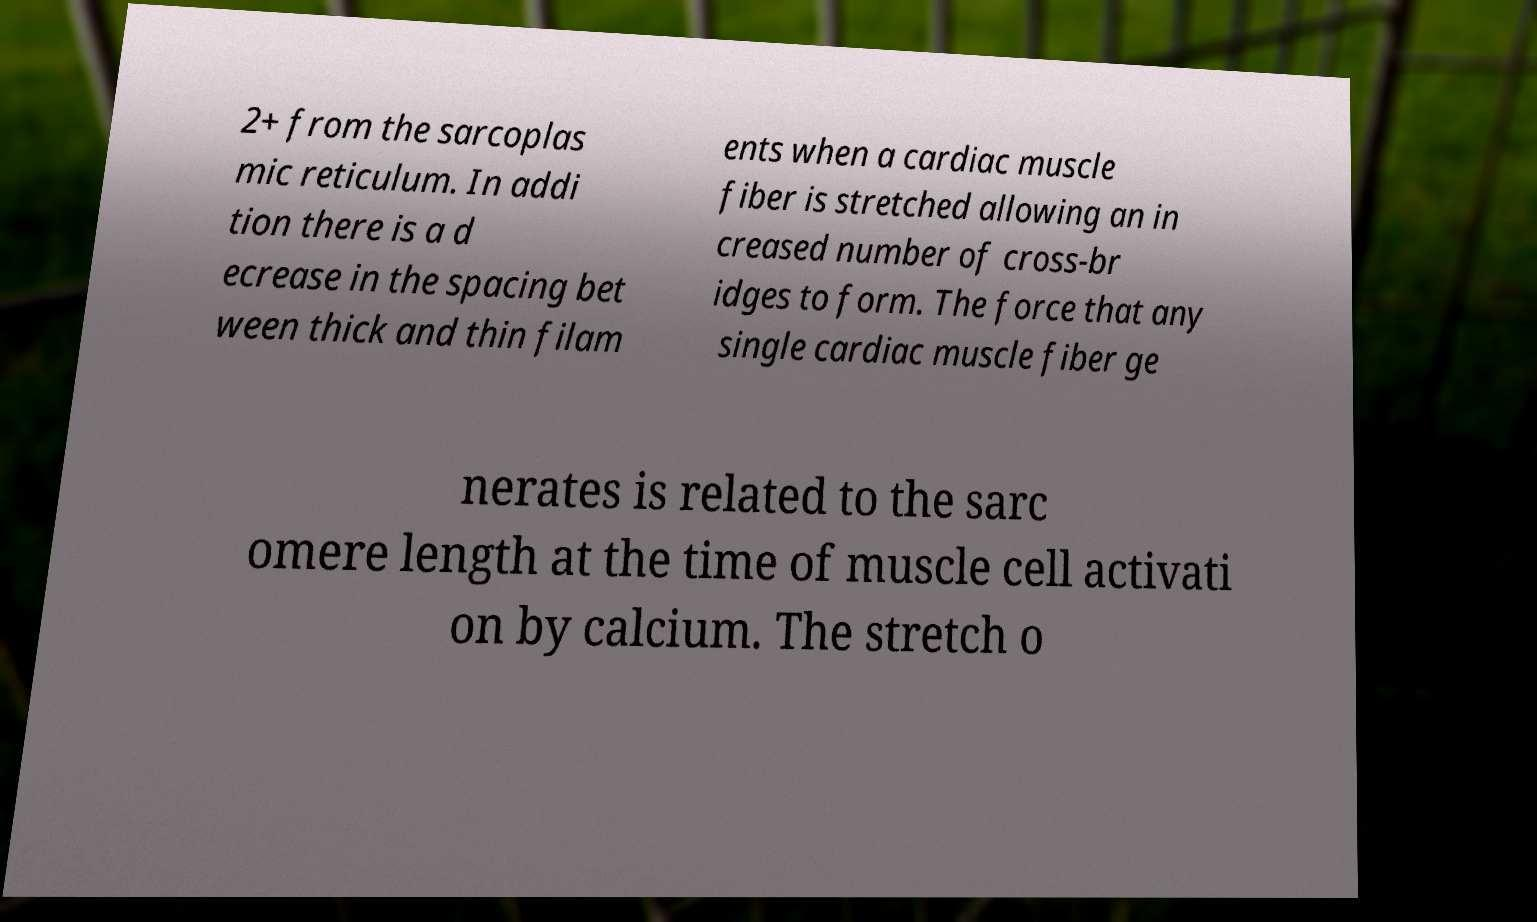Please read and relay the text visible in this image. What does it say? 2+ from the sarcoplas mic reticulum. In addi tion there is a d ecrease in the spacing bet ween thick and thin filam ents when a cardiac muscle fiber is stretched allowing an in creased number of cross-br idges to form. The force that any single cardiac muscle fiber ge nerates is related to the sarc omere length at the time of muscle cell activati on by calcium. The stretch o 